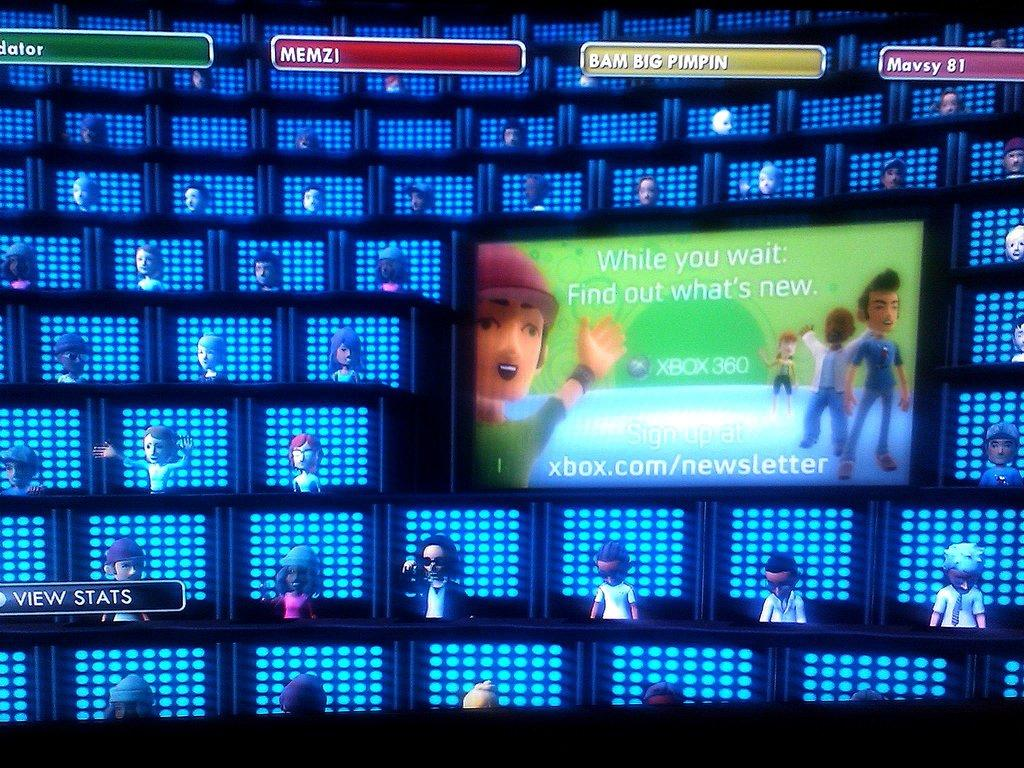<image>
Share a concise interpretation of the image provided. A screen showing a large number of Xbox characters. 